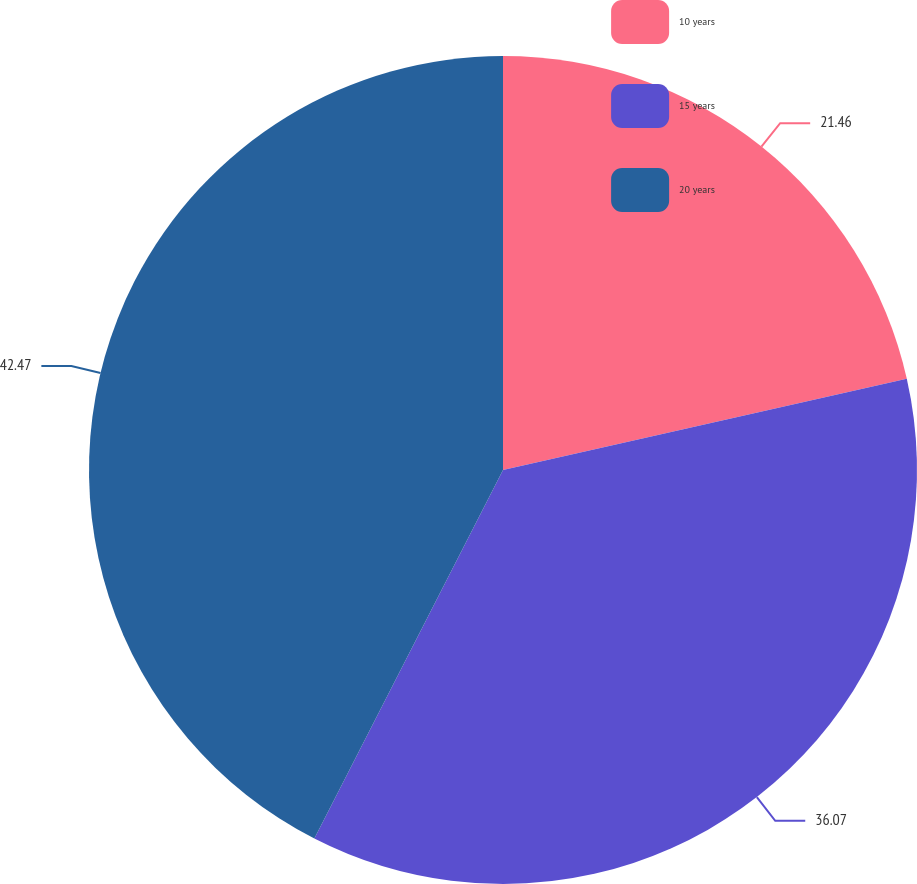Convert chart. <chart><loc_0><loc_0><loc_500><loc_500><pie_chart><fcel>10 years<fcel>15 years<fcel>20 years<nl><fcel>21.46%<fcel>36.07%<fcel>42.47%<nl></chart> 